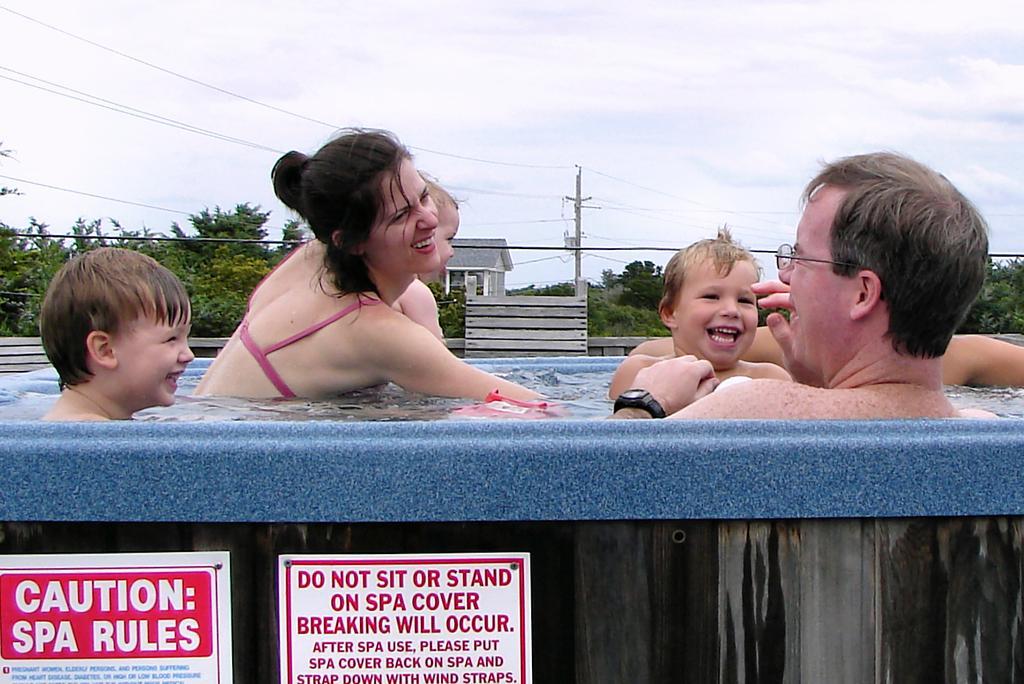Describe this image in one or two sentences. In the image we can see there are people and children, they are smiling and here we can see a man wearing spectacles and a wrist watch. Here we can see the water, house, board and text on the board. Here we can see the trees, the electric pole, electric wires and the sky 